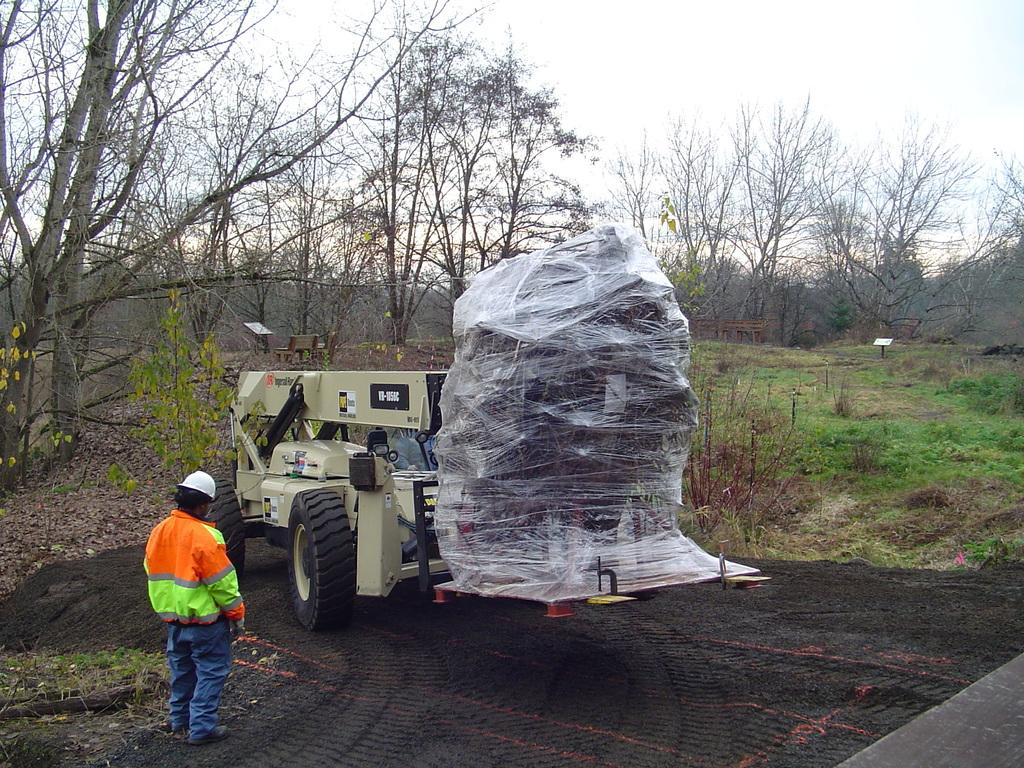What can be seen in the sky in the image? There is a sky in the image. What type of natural elements are present in the image? There are trees, plants, and grass in the image. What type of seating is available in the image? There is a bench in the image. What mode of transportation is visible in the image? There is a vehicle in the image. Who or what is standing in the image? There is a person standing in the image. How much was the payment for the person's journey in the image? There is no information about a payment or journey in the image; it only shows a person standing near a vehicle. 